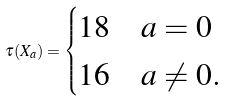<formula> <loc_0><loc_0><loc_500><loc_500>\tau ( X _ { a } ) = \begin{cases} 1 8 & a = 0 \\ 1 6 & a \ne 0 . \end{cases}</formula> 